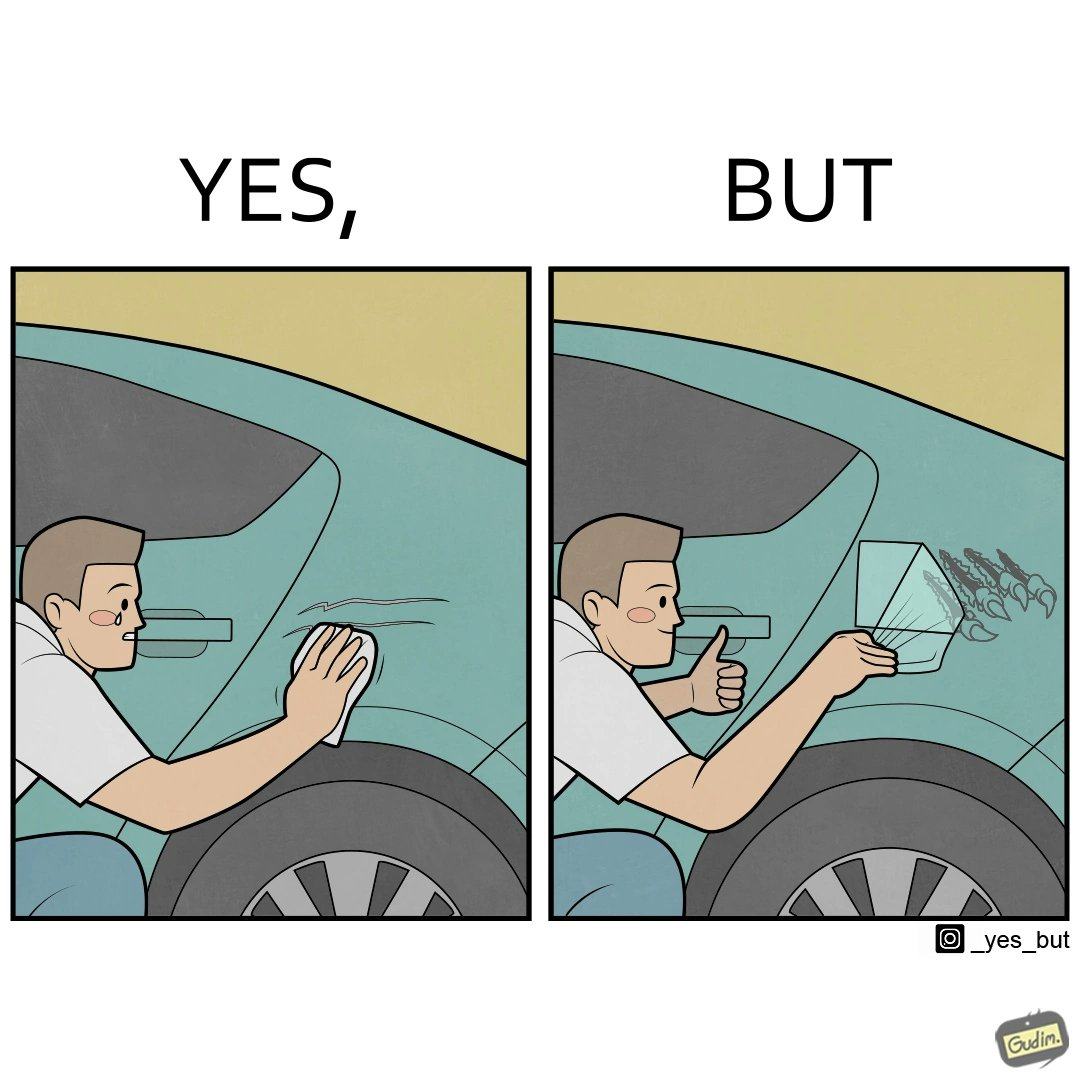Explain the humor or irony in this image. The image is ironic, because the person who cries over the scratches on his car but applies stickers on his car happily which is quite dual nature of the person 